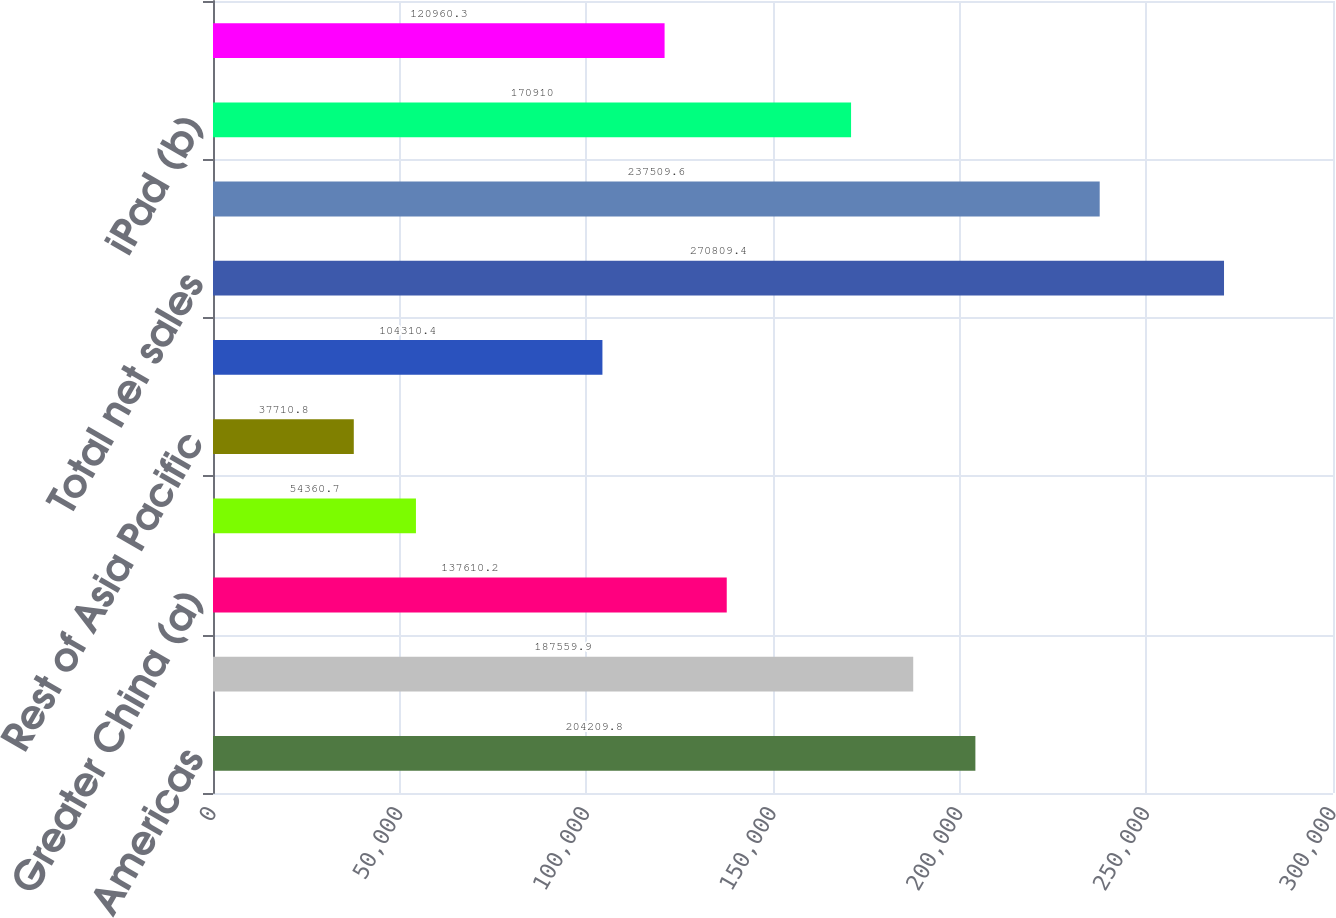Convert chart. <chart><loc_0><loc_0><loc_500><loc_500><bar_chart><fcel>Americas<fcel>Europe<fcel>Greater China (a)<fcel>Japan<fcel>Rest of Asia Pacific<fcel>Retail<fcel>Total net sales<fcel>iPhone (b)<fcel>iPad (b)<fcel>Mac (b)<nl><fcel>204210<fcel>187560<fcel>137610<fcel>54360.7<fcel>37710.8<fcel>104310<fcel>270809<fcel>237510<fcel>170910<fcel>120960<nl></chart> 